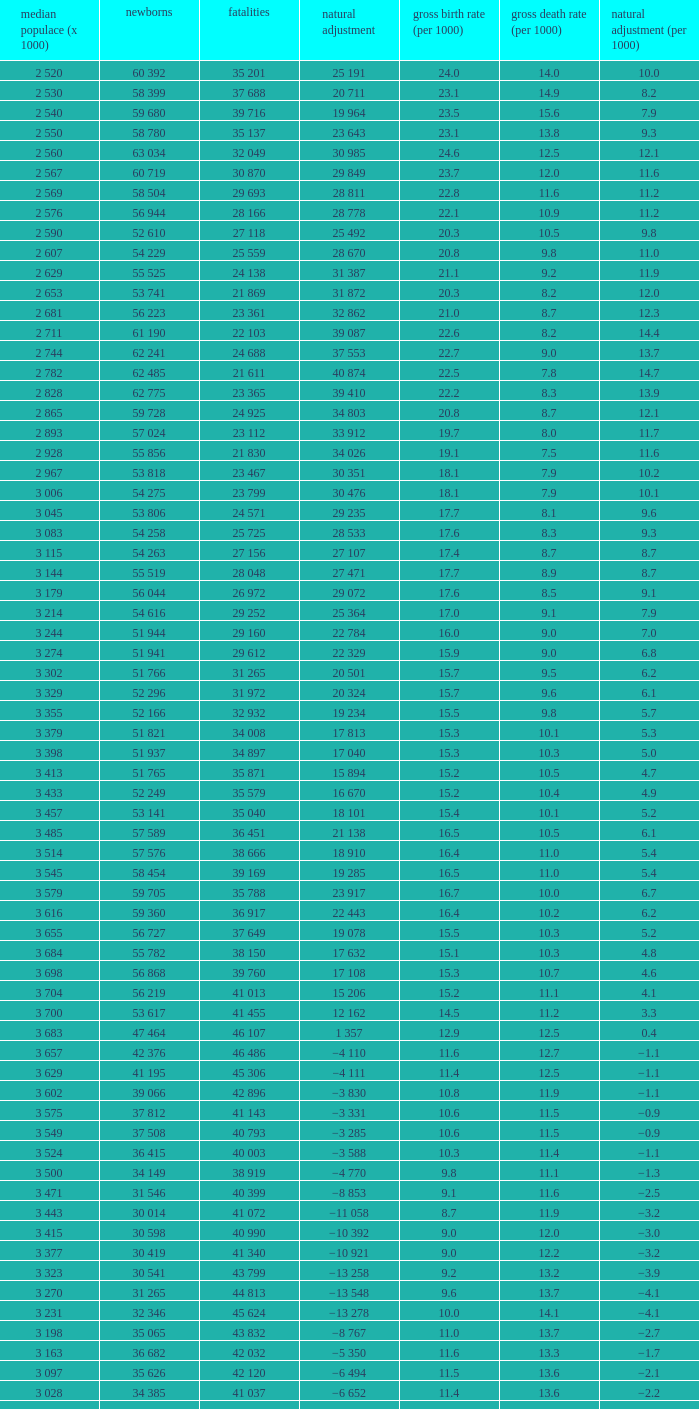Which Live births have a Natural change (per 1000) of 12.0? 53 741. 